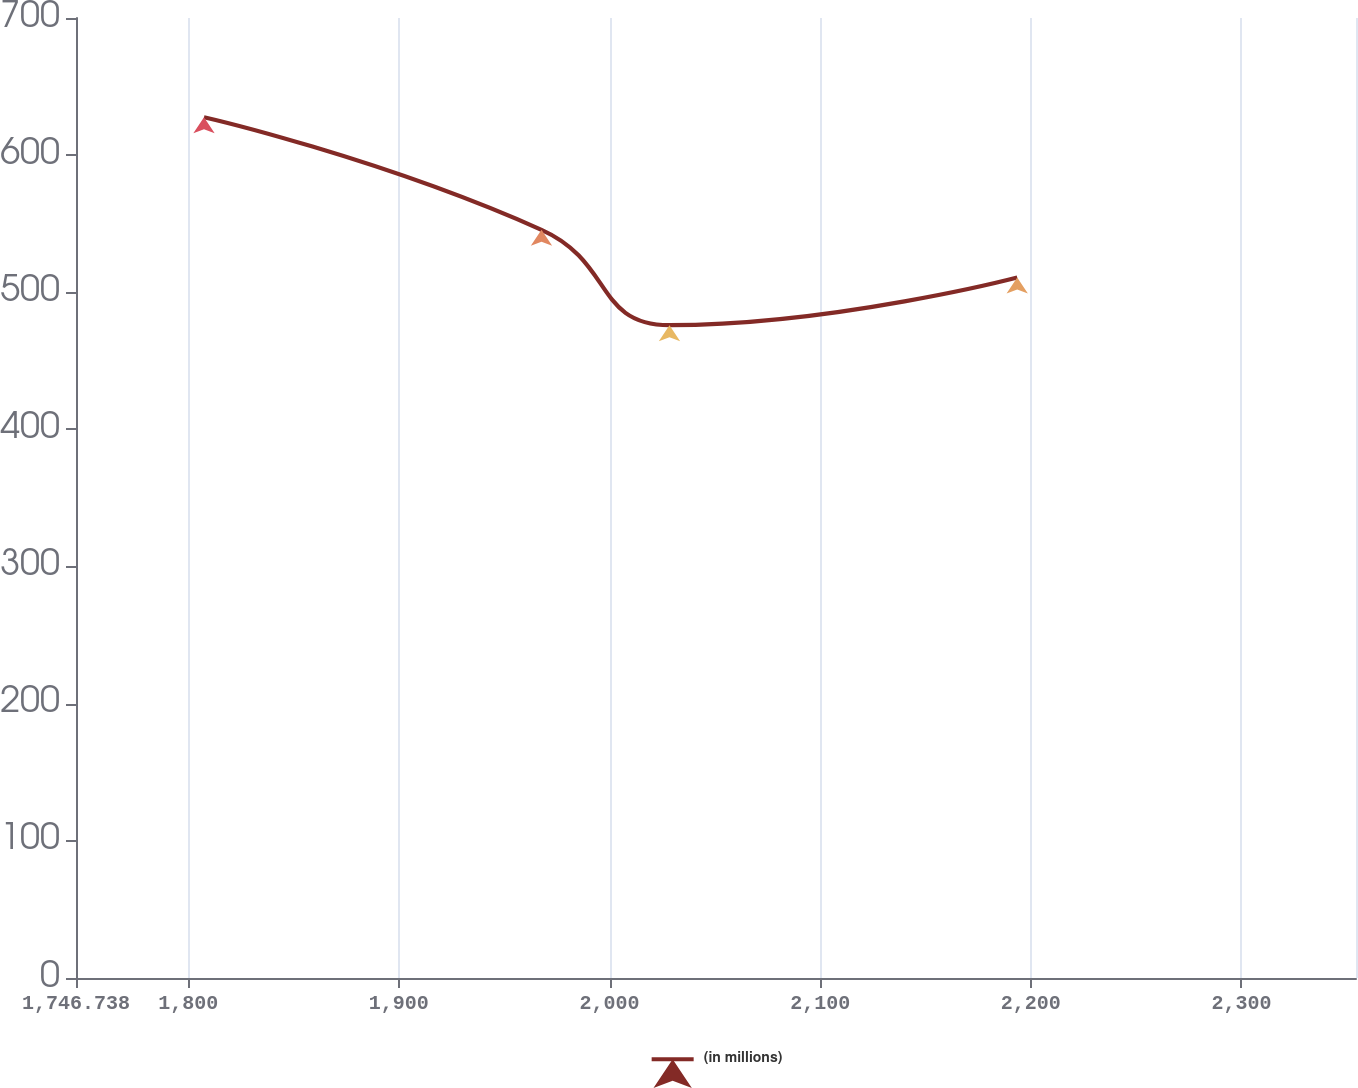Convert chart. <chart><loc_0><loc_0><loc_500><loc_500><line_chart><ecel><fcel>(in millions)<nl><fcel>1807.5<fcel>627.67<nl><fcel>1967.71<fcel>545.53<nl><fcel>2028.47<fcel>476.03<nl><fcel>2193.54<fcel>510.78<nl><fcel>2415.12<fcel>280.18<nl></chart> 